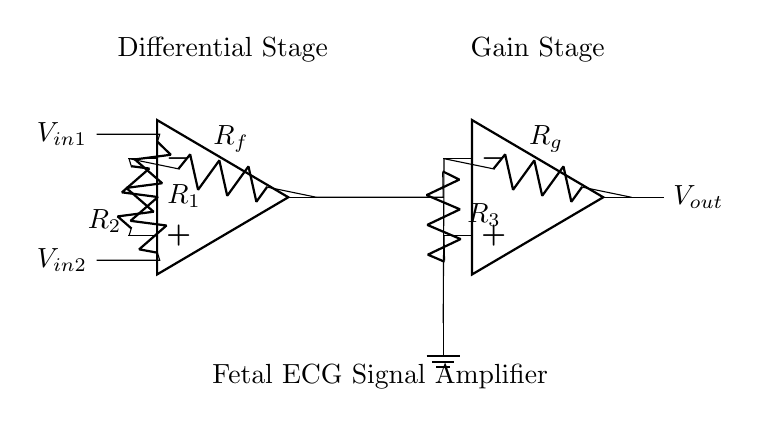What is the primary function of the operational amplifiers in this circuit? The operational amplifiers are used to amplify the difference between the two input signals, enabling the differentiation between noise and the fetal ECG signal.
Answer: Amplification What do the resistors labeled R1 and R2 represent? R1 and R2 are input resistors that help in setting the gain and determining the input impedance of the differential amplifier.
Answer: Input resistors How many operational amplifiers are present in this circuit? There are two operational amplifiers in the differential amplifier configuration.
Answer: Two What is the purpose of the feedback resistor Rf? The feedback resistor Rf is used to set the gain of the first operational amplifier by providing feedback to its inverting input.
Answer: Gain setting What is the output of this circuit labeled as? The output of the circuit is labeled as Vout, which represents the amplified differential voltage resulting from the input signals.
Answer: Vout What does the connection of R3 to the second operational amplifier signify in terms of circuit function? The connection of R3 to the second operational amplifier indicates that R3 is part of the gain stage, affecting the gain applied to the output signal of the first op-amp.
Answer: Gain stage interaction 